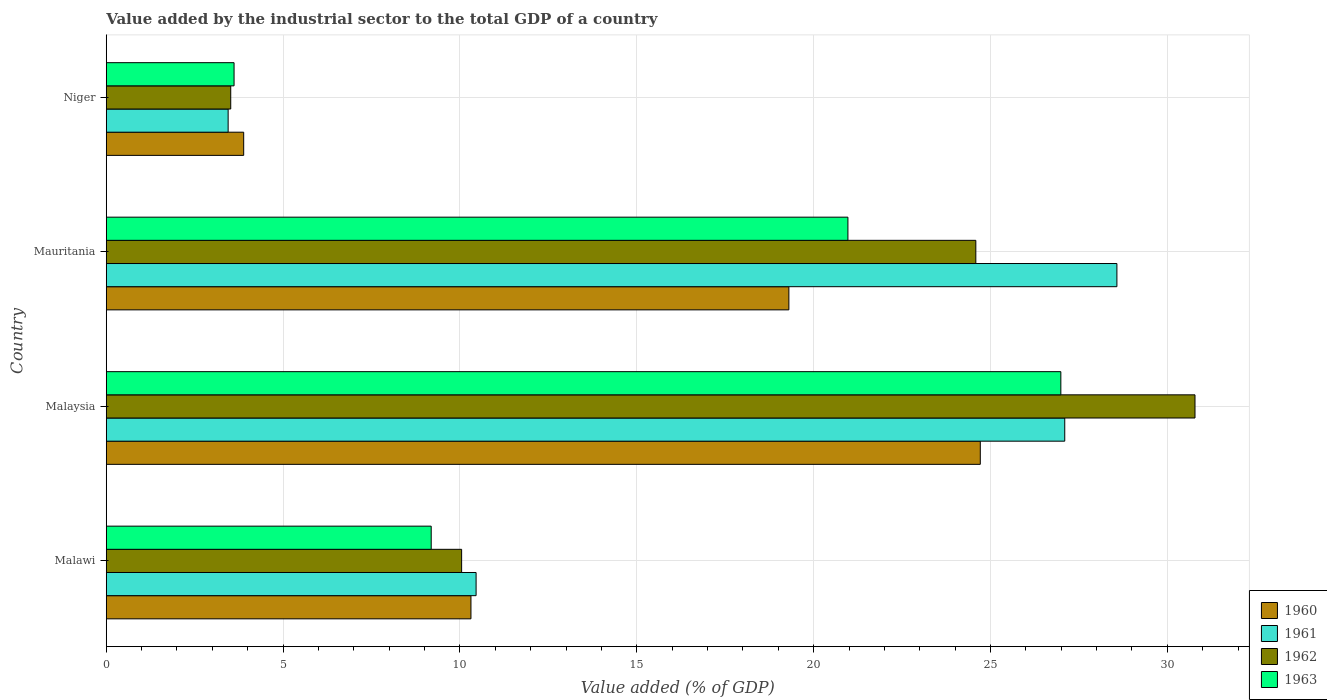How many different coloured bars are there?
Your answer should be very brief. 4. How many groups of bars are there?
Offer a very short reply. 4. Are the number of bars per tick equal to the number of legend labels?
Your answer should be compact. Yes. Are the number of bars on each tick of the Y-axis equal?
Your response must be concise. Yes. How many bars are there on the 4th tick from the bottom?
Provide a short and direct response. 4. What is the label of the 4th group of bars from the top?
Give a very brief answer. Malawi. In how many cases, is the number of bars for a given country not equal to the number of legend labels?
Your response must be concise. 0. What is the value added by the industrial sector to the total GDP in 1961 in Niger?
Give a very brief answer. 3.45. Across all countries, what is the maximum value added by the industrial sector to the total GDP in 1960?
Your answer should be very brief. 24.71. Across all countries, what is the minimum value added by the industrial sector to the total GDP in 1961?
Your answer should be compact. 3.45. In which country was the value added by the industrial sector to the total GDP in 1962 maximum?
Provide a succinct answer. Malaysia. In which country was the value added by the industrial sector to the total GDP in 1960 minimum?
Give a very brief answer. Niger. What is the total value added by the industrial sector to the total GDP in 1962 in the graph?
Make the answer very short. 68.93. What is the difference between the value added by the industrial sector to the total GDP in 1960 in Malawi and that in Mauritania?
Offer a terse response. -8.99. What is the difference between the value added by the industrial sector to the total GDP in 1962 in Malawi and the value added by the industrial sector to the total GDP in 1961 in Niger?
Give a very brief answer. 6.6. What is the average value added by the industrial sector to the total GDP in 1962 per country?
Your answer should be very brief. 17.23. What is the difference between the value added by the industrial sector to the total GDP in 1960 and value added by the industrial sector to the total GDP in 1961 in Malaysia?
Ensure brevity in your answer.  -2.39. In how many countries, is the value added by the industrial sector to the total GDP in 1961 greater than 23 %?
Provide a succinct answer. 2. What is the ratio of the value added by the industrial sector to the total GDP in 1962 in Malawi to that in Niger?
Your response must be concise. 2.85. What is the difference between the highest and the second highest value added by the industrial sector to the total GDP in 1962?
Offer a very short reply. 6.2. What is the difference between the highest and the lowest value added by the industrial sector to the total GDP in 1961?
Offer a terse response. 25.13. What does the 3rd bar from the top in Niger represents?
Give a very brief answer. 1961. What does the 3rd bar from the bottom in Mauritania represents?
Give a very brief answer. 1962. How many bars are there?
Give a very brief answer. 16. Are all the bars in the graph horizontal?
Provide a short and direct response. Yes. How many countries are there in the graph?
Keep it short and to the point. 4. What is the difference between two consecutive major ticks on the X-axis?
Provide a succinct answer. 5. Are the values on the major ticks of X-axis written in scientific E-notation?
Make the answer very short. No. How many legend labels are there?
Ensure brevity in your answer.  4. What is the title of the graph?
Your response must be concise. Value added by the industrial sector to the total GDP of a country. Does "1988" appear as one of the legend labels in the graph?
Your answer should be very brief. No. What is the label or title of the X-axis?
Provide a succinct answer. Value added (% of GDP). What is the Value added (% of GDP) in 1960 in Malawi?
Give a very brief answer. 10.31. What is the Value added (% of GDP) of 1961 in Malawi?
Offer a very short reply. 10.46. What is the Value added (% of GDP) in 1962 in Malawi?
Offer a very short reply. 10.05. What is the Value added (% of GDP) in 1963 in Malawi?
Ensure brevity in your answer.  9.19. What is the Value added (% of GDP) in 1960 in Malaysia?
Your answer should be very brief. 24.71. What is the Value added (% of GDP) of 1961 in Malaysia?
Make the answer very short. 27.1. What is the Value added (% of GDP) in 1962 in Malaysia?
Offer a very short reply. 30.78. What is the Value added (% of GDP) of 1963 in Malaysia?
Your answer should be very brief. 26.99. What is the Value added (% of GDP) in 1960 in Mauritania?
Provide a short and direct response. 19.3. What is the Value added (% of GDP) in 1961 in Mauritania?
Ensure brevity in your answer.  28.57. What is the Value added (% of GDP) of 1962 in Mauritania?
Your response must be concise. 24.59. What is the Value added (% of GDP) in 1963 in Mauritania?
Provide a short and direct response. 20.97. What is the Value added (% of GDP) in 1960 in Niger?
Offer a very short reply. 3.89. What is the Value added (% of GDP) in 1961 in Niger?
Provide a succinct answer. 3.45. What is the Value added (% of GDP) in 1962 in Niger?
Provide a short and direct response. 3.52. What is the Value added (% of GDP) in 1963 in Niger?
Provide a succinct answer. 3.61. Across all countries, what is the maximum Value added (% of GDP) of 1960?
Provide a succinct answer. 24.71. Across all countries, what is the maximum Value added (% of GDP) in 1961?
Make the answer very short. 28.57. Across all countries, what is the maximum Value added (% of GDP) in 1962?
Your answer should be compact. 30.78. Across all countries, what is the maximum Value added (% of GDP) in 1963?
Your answer should be compact. 26.99. Across all countries, what is the minimum Value added (% of GDP) of 1960?
Ensure brevity in your answer.  3.89. Across all countries, what is the minimum Value added (% of GDP) in 1961?
Provide a short and direct response. 3.45. Across all countries, what is the minimum Value added (% of GDP) of 1962?
Make the answer very short. 3.52. Across all countries, what is the minimum Value added (% of GDP) of 1963?
Your answer should be compact. 3.61. What is the total Value added (% of GDP) of 1960 in the graph?
Your answer should be compact. 58.21. What is the total Value added (% of GDP) of 1961 in the graph?
Keep it short and to the point. 69.58. What is the total Value added (% of GDP) in 1962 in the graph?
Your answer should be very brief. 68.93. What is the total Value added (% of GDP) of 1963 in the graph?
Make the answer very short. 60.76. What is the difference between the Value added (% of GDP) in 1960 in Malawi and that in Malaysia?
Ensure brevity in your answer.  -14.4. What is the difference between the Value added (% of GDP) in 1961 in Malawi and that in Malaysia?
Make the answer very short. -16.64. What is the difference between the Value added (% of GDP) in 1962 in Malawi and that in Malaysia?
Provide a short and direct response. -20.73. What is the difference between the Value added (% of GDP) of 1963 in Malawi and that in Malaysia?
Your answer should be very brief. -17.8. What is the difference between the Value added (% of GDP) in 1960 in Malawi and that in Mauritania?
Make the answer very short. -8.99. What is the difference between the Value added (% of GDP) of 1961 in Malawi and that in Mauritania?
Make the answer very short. -18.12. What is the difference between the Value added (% of GDP) in 1962 in Malawi and that in Mauritania?
Provide a succinct answer. -14.54. What is the difference between the Value added (% of GDP) in 1963 in Malawi and that in Mauritania?
Your answer should be compact. -11.78. What is the difference between the Value added (% of GDP) of 1960 in Malawi and that in Niger?
Offer a terse response. 6.43. What is the difference between the Value added (% of GDP) of 1961 in Malawi and that in Niger?
Your answer should be very brief. 7.01. What is the difference between the Value added (% of GDP) of 1962 in Malawi and that in Niger?
Offer a very short reply. 6.53. What is the difference between the Value added (% of GDP) of 1963 in Malawi and that in Niger?
Offer a very short reply. 5.57. What is the difference between the Value added (% of GDP) in 1960 in Malaysia and that in Mauritania?
Your answer should be compact. 5.41. What is the difference between the Value added (% of GDP) in 1961 in Malaysia and that in Mauritania?
Give a very brief answer. -1.47. What is the difference between the Value added (% of GDP) in 1962 in Malaysia and that in Mauritania?
Keep it short and to the point. 6.2. What is the difference between the Value added (% of GDP) of 1963 in Malaysia and that in Mauritania?
Ensure brevity in your answer.  6.02. What is the difference between the Value added (% of GDP) of 1960 in Malaysia and that in Niger?
Offer a very short reply. 20.83. What is the difference between the Value added (% of GDP) of 1961 in Malaysia and that in Niger?
Offer a terse response. 23.65. What is the difference between the Value added (% of GDP) in 1962 in Malaysia and that in Niger?
Offer a terse response. 27.26. What is the difference between the Value added (% of GDP) of 1963 in Malaysia and that in Niger?
Make the answer very short. 23.38. What is the difference between the Value added (% of GDP) in 1960 in Mauritania and that in Niger?
Provide a succinct answer. 15.41. What is the difference between the Value added (% of GDP) of 1961 in Mauritania and that in Niger?
Ensure brevity in your answer.  25.13. What is the difference between the Value added (% of GDP) of 1962 in Mauritania and that in Niger?
Your answer should be very brief. 21.07. What is the difference between the Value added (% of GDP) in 1963 in Mauritania and that in Niger?
Your answer should be very brief. 17.36. What is the difference between the Value added (% of GDP) in 1960 in Malawi and the Value added (% of GDP) in 1961 in Malaysia?
Provide a succinct answer. -16.79. What is the difference between the Value added (% of GDP) in 1960 in Malawi and the Value added (% of GDP) in 1962 in Malaysia?
Your answer should be compact. -20.47. What is the difference between the Value added (% of GDP) of 1960 in Malawi and the Value added (% of GDP) of 1963 in Malaysia?
Your response must be concise. -16.68. What is the difference between the Value added (% of GDP) of 1961 in Malawi and the Value added (% of GDP) of 1962 in Malaysia?
Offer a terse response. -20.33. What is the difference between the Value added (% of GDP) of 1961 in Malawi and the Value added (% of GDP) of 1963 in Malaysia?
Keep it short and to the point. -16.53. What is the difference between the Value added (% of GDP) in 1962 in Malawi and the Value added (% of GDP) in 1963 in Malaysia?
Provide a succinct answer. -16.94. What is the difference between the Value added (% of GDP) in 1960 in Malawi and the Value added (% of GDP) in 1961 in Mauritania?
Give a very brief answer. -18.26. What is the difference between the Value added (% of GDP) in 1960 in Malawi and the Value added (% of GDP) in 1962 in Mauritania?
Provide a short and direct response. -14.27. What is the difference between the Value added (% of GDP) of 1960 in Malawi and the Value added (% of GDP) of 1963 in Mauritania?
Your answer should be very brief. -10.66. What is the difference between the Value added (% of GDP) in 1961 in Malawi and the Value added (% of GDP) in 1962 in Mauritania?
Make the answer very short. -14.13. What is the difference between the Value added (% of GDP) in 1961 in Malawi and the Value added (% of GDP) in 1963 in Mauritania?
Provide a short and direct response. -10.51. What is the difference between the Value added (% of GDP) in 1962 in Malawi and the Value added (% of GDP) in 1963 in Mauritania?
Provide a succinct answer. -10.92. What is the difference between the Value added (% of GDP) of 1960 in Malawi and the Value added (% of GDP) of 1961 in Niger?
Your answer should be very brief. 6.86. What is the difference between the Value added (% of GDP) of 1960 in Malawi and the Value added (% of GDP) of 1962 in Niger?
Your response must be concise. 6.79. What is the difference between the Value added (% of GDP) in 1960 in Malawi and the Value added (% of GDP) in 1963 in Niger?
Your response must be concise. 6.7. What is the difference between the Value added (% of GDP) of 1961 in Malawi and the Value added (% of GDP) of 1962 in Niger?
Provide a short and direct response. 6.94. What is the difference between the Value added (% of GDP) in 1961 in Malawi and the Value added (% of GDP) in 1963 in Niger?
Your answer should be very brief. 6.84. What is the difference between the Value added (% of GDP) in 1962 in Malawi and the Value added (% of GDP) in 1963 in Niger?
Your response must be concise. 6.43. What is the difference between the Value added (% of GDP) in 1960 in Malaysia and the Value added (% of GDP) in 1961 in Mauritania?
Ensure brevity in your answer.  -3.86. What is the difference between the Value added (% of GDP) of 1960 in Malaysia and the Value added (% of GDP) of 1962 in Mauritania?
Your answer should be compact. 0.13. What is the difference between the Value added (% of GDP) in 1960 in Malaysia and the Value added (% of GDP) in 1963 in Mauritania?
Offer a terse response. 3.74. What is the difference between the Value added (% of GDP) in 1961 in Malaysia and the Value added (% of GDP) in 1962 in Mauritania?
Provide a succinct answer. 2.51. What is the difference between the Value added (% of GDP) of 1961 in Malaysia and the Value added (% of GDP) of 1963 in Mauritania?
Your response must be concise. 6.13. What is the difference between the Value added (% of GDP) in 1962 in Malaysia and the Value added (% of GDP) in 1963 in Mauritania?
Ensure brevity in your answer.  9.81. What is the difference between the Value added (% of GDP) in 1960 in Malaysia and the Value added (% of GDP) in 1961 in Niger?
Offer a terse response. 21.27. What is the difference between the Value added (% of GDP) in 1960 in Malaysia and the Value added (% of GDP) in 1962 in Niger?
Give a very brief answer. 21.19. What is the difference between the Value added (% of GDP) in 1960 in Malaysia and the Value added (% of GDP) in 1963 in Niger?
Provide a short and direct response. 21.1. What is the difference between the Value added (% of GDP) of 1961 in Malaysia and the Value added (% of GDP) of 1962 in Niger?
Give a very brief answer. 23.58. What is the difference between the Value added (% of GDP) in 1961 in Malaysia and the Value added (% of GDP) in 1963 in Niger?
Ensure brevity in your answer.  23.49. What is the difference between the Value added (% of GDP) in 1962 in Malaysia and the Value added (% of GDP) in 1963 in Niger?
Give a very brief answer. 27.17. What is the difference between the Value added (% of GDP) in 1960 in Mauritania and the Value added (% of GDP) in 1961 in Niger?
Give a very brief answer. 15.85. What is the difference between the Value added (% of GDP) in 1960 in Mauritania and the Value added (% of GDP) in 1962 in Niger?
Your response must be concise. 15.78. What is the difference between the Value added (% of GDP) in 1960 in Mauritania and the Value added (% of GDP) in 1963 in Niger?
Keep it short and to the point. 15.69. What is the difference between the Value added (% of GDP) of 1961 in Mauritania and the Value added (% of GDP) of 1962 in Niger?
Your answer should be very brief. 25.05. What is the difference between the Value added (% of GDP) of 1961 in Mauritania and the Value added (% of GDP) of 1963 in Niger?
Provide a short and direct response. 24.96. What is the difference between the Value added (% of GDP) of 1962 in Mauritania and the Value added (% of GDP) of 1963 in Niger?
Provide a short and direct response. 20.97. What is the average Value added (% of GDP) in 1960 per country?
Ensure brevity in your answer.  14.55. What is the average Value added (% of GDP) of 1961 per country?
Keep it short and to the point. 17.39. What is the average Value added (% of GDP) of 1962 per country?
Make the answer very short. 17.23. What is the average Value added (% of GDP) in 1963 per country?
Your response must be concise. 15.19. What is the difference between the Value added (% of GDP) in 1960 and Value added (% of GDP) in 1961 in Malawi?
Offer a terse response. -0.15. What is the difference between the Value added (% of GDP) in 1960 and Value added (% of GDP) in 1962 in Malawi?
Make the answer very short. 0.26. What is the difference between the Value added (% of GDP) in 1960 and Value added (% of GDP) in 1963 in Malawi?
Provide a short and direct response. 1.12. What is the difference between the Value added (% of GDP) in 1961 and Value added (% of GDP) in 1962 in Malawi?
Provide a short and direct response. 0.41. What is the difference between the Value added (% of GDP) in 1961 and Value added (% of GDP) in 1963 in Malawi?
Your response must be concise. 1.27. What is the difference between the Value added (% of GDP) in 1962 and Value added (% of GDP) in 1963 in Malawi?
Keep it short and to the point. 0.86. What is the difference between the Value added (% of GDP) of 1960 and Value added (% of GDP) of 1961 in Malaysia?
Keep it short and to the point. -2.39. What is the difference between the Value added (% of GDP) of 1960 and Value added (% of GDP) of 1962 in Malaysia?
Ensure brevity in your answer.  -6.07. What is the difference between the Value added (% of GDP) of 1960 and Value added (% of GDP) of 1963 in Malaysia?
Your response must be concise. -2.28. What is the difference between the Value added (% of GDP) in 1961 and Value added (% of GDP) in 1962 in Malaysia?
Offer a terse response. -3.68. What is the difference between the Value added (% of GDP) of 1961 and Value added (% of GDP) of 1963 in Malaysia?
Ensure brevity in your answer.  0.11. What is the difference between the Value added (% of GDP) of 1962 and Value added (% of GDP) of 1963 in Malaysia?
Give a very brief answer. 3.79. What is the difference between the Value added (% of GDP) in 1960 and Value added (% of GDP) in 1961 in Mauritania?
Offer a terse response. -9.27. What is the difference between the Value added (% of GDP) in 1960 and Value added (% of GDP) in 1962 in Mauritania?
Provide a succinct answer. -5.29. What is the difference between the Value added (% of GDP) of 1960 and Value added (% of GDP) of 1963 in Mauritania?
Provide a short and direct response. -1.67. What is the difference between the Value added (% of GDP) of 1961 and Value added (% of GDP) of 1962 in Mauritania?
Give a very brief answer. 3.99. What is the difference between the Value added (% of GDP) in 1961 and Value added (% of GDP) in 1963 in Mauritania?
Provide a succinct answer. 7.6. What is the difference between the Value added (% of GDP) of 1962 and Value added (% of GDP) of 1963 in Mauritania?
Your answer should be compact. 3.62. What is the difference between the Value added (% of GDP) of 1960 and Value added (% of GDP) of 1961 in Niger?
Your answer should be very brief. 0.44. What is the difference between the Value added (% of GDP) in 1960 and Value added (% of GDP) in 1962 in Niger?
Your answer should be compact. 0.37. What is the difference between the Value added (% of GDP) in 1960 and Value added (% of GDP) in 1963 in Niger?
Make the answer very short. 0.27. What is the difference between the Value added (% of GDP) in 1961 and Value added (% of GDP) in 1962 in Niger?
Provide a short and direct response. -0.07. What is the difference between the Value added (% of GDP) of 1961 and Value added (% of GDP) of 1963 in Niger?
Your response must be concise. -0.17. What is the difference between the Value added (% of GDP) of 1962 and Value added (% of GDP) of 1963 in Niger?
Offer a terse response. -0.09. What is the ratio of the Value added (% of GDP) of 1960 in Malawi to that in Malaysia?
Provide a succinct answer. 0.42. What is the ratio of the Value added (% of GDP) of 1961 in Malawi to that in Malaysia?
Offer a very short reply. 0.39. What is the ratio of the Value added (% of GDP) of 1962 in Malawi to that in Malaysia?
Offer a very short reply. 0.33. What is the ratio of the Value added (% of GDP) of 1963 in Malawi to that in Malaysia?
Ensure brevity in your answer.  0.34. What is the ratio of the Value added (% of GDP) of 1960 in Malawi to that in Mauritania?
Keep it short and to the point. 0.53. What is the ratio of the Value added (% of GDP) of 1961 in Malawi to that in Mauritania?
Give a very brief answer. 0.37. What is the ratio of the Value added (% of GDP) in 1962 in Malawi to that in Mauritania?
Make the answer very short. 0.41. What is the ratio of the Value added (% of GDP) of 1963 in Malawi to that in Mauritania?
Ensure brevity in your answer.  0.44. What is the ratio of the Value added (% of GDP) of 1960 in Malawi to that in Niger?
Your response must be concise. 2.65. What is the ratio of the Value added (% of GDP) of 1961 in Malawi to that in Niger?
Your response must be concise. 3.03. What is the ratio of the Value added (% of GDP) in 1962 in Malawi to that in Niger?
Provide a succinct answer. 2.85. What is the ratio of the Value added (% of GDP) of 1963 in Malawi to that in Niger?
Provide a short and direct response. 2.54. What is the ratio of the Value added (% of GDP) in 1960 in Malaysia to that in Mauritania?
Keep it short and to the point. 1.28. What is the ratio of the Value added (% of GDP) in 1961 in Malaysia to that in Mauritania?
Make the answer very short. 0.95. What is the ratio of the Value added (% of GDP) in 1962 in Malaysia to that in Mauritania?
Give a very brief answer. 1.25. What is the ratio of the Value added (% of GDP) of 1963 in Malaysia to that in Mauritania?
Provide a short and direct response. 1.29. What is the ratio of the Value added (% of GDP) in 1960 in Malaysia to that in Niger?
Provide a short and direct response. 6.36. What is the ratio of the Value added (% of GDP) in 1961 in Malaysia to that in Niger?
Offer a very short reply. 7.86. What is the ratio of the Value added (% of GDP) of 1962 in Malaysia to that in Niger?
Keep it short and to the point. 8.75. What is the ratio of the Value added (% of GDP) of 1963 in Malaysia to that in Niger?
Give a very brief answer. 7.47. What is the ratio of the Value added (% of GDP) of 1960 in Mauritania to that in Niger?
Provide a short and direct response. 4.97. What is the ratio of the Value added (% of GDP) of 1961 in Mauritania to that in Niger?
Your answer should be very brief. 8.29. What is the ratio of the Value added (% of GDP) of 1962 in Mauritania to that in Niger?
Make the answer very short. 6.99. What is the ratio of the Value added (% of GDP) in 1963 in Mauritania to that in Niger?
Keep it short and to the point. 5.8. What is the difference between the highest and the second highest Value added (% of GDP) in 1960?
Offer a very short reply. 5.41. What is the difference between the highest and the second highest Value added (% of GDP) in 1961?
Give a very brief answer. 1.47. What is the difference between the highest and the second highest Value added (% of GDP) in 1962?
Provide a short and direct response. 6.2. What is the difference between the highest and the second highest Value added (% of GDP) of 1963?
Give a very brief answer. 6.02. What is the difference between the highest and the lowest Value added (% of GDP) in 1960?
Offer a very short reply. 20.83. What is the difference between the highest and the lowest Value added (% of GDP) in 1961?
Ensure brevity in your answer.  25.13. What is the difference between the highest and the lowest Value added (% of GDP) in 1962?
Keep it short and to the point. 27.26. What is the difference between the highest and the lowest Value added (% of GDP) in 1963?
Your response must be concise. 23.38. 